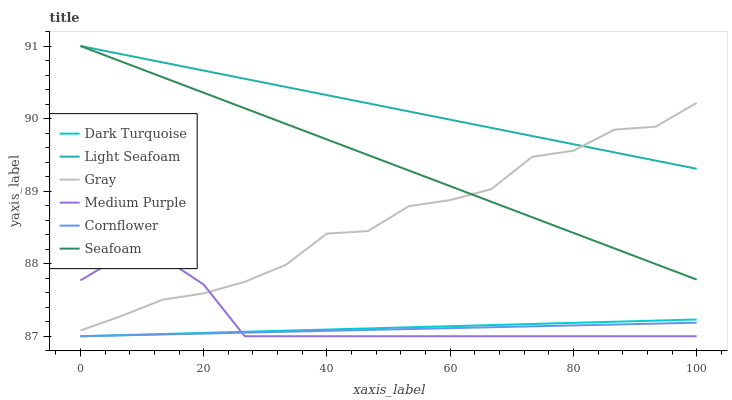Does Cornflower have the minimum area under the curve?
Answer yes or no. Yes. Does Light Seafoam have the maximum area under the curve?
Answer yes or no. Yes. Does Gray have the minimum area under the curve?
Answer yes or no. No. Does Gray have the maximum area under the curve?
Answer yes or no. No. Is Dark Turquoise the smoothest?
Answer yes or no. Yes. Is Gray the roughest?
Answer yes or no. Yes. Is Gray the smoothest?
Answer yes or no. No. Is Dark Turquoise the roughest?
Answer yes or no. No. Does Cornflower have the lowest value?
Answer yes or no. Yes. Does Gray have the lowest value?
Answer yes or no. No. Does Light Seafoam have the highest value?
Answer yes or no. Yes. Does Gray have the highest value?
Answer yes or no. No. Is Dark Turquoise less than Seafoam?
Answer yes or no. Yes. Is Seafoam greater than Medium Purple?
Answer yes or no. Yes. Does Seafoam intersect Light Seafoam?
Answer yes or no. Yes. Is Seafoam less than Light Seafoam?
Answer yes or no. No. Is Seafoam greater than Light Seafoam?
Answer yes or no. No. Does Dark Turquoise intersect Seafoam?
Answer yes or no. No. 